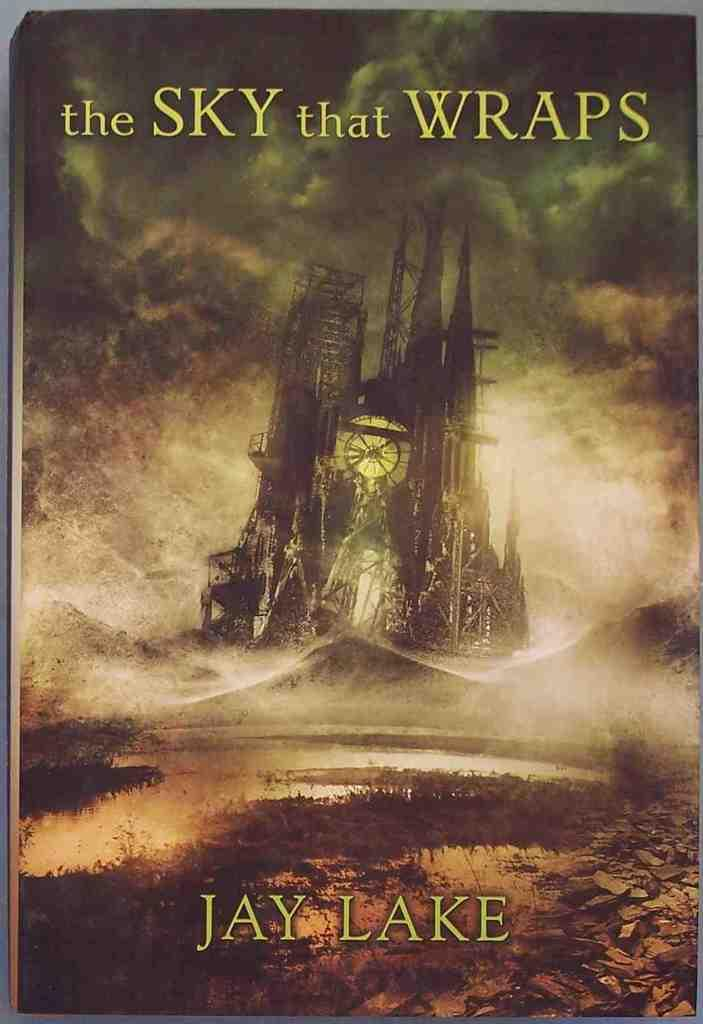<image>
Render a clear and concise summary of the photo. A book by Jay Lake has a castle on the cover. 